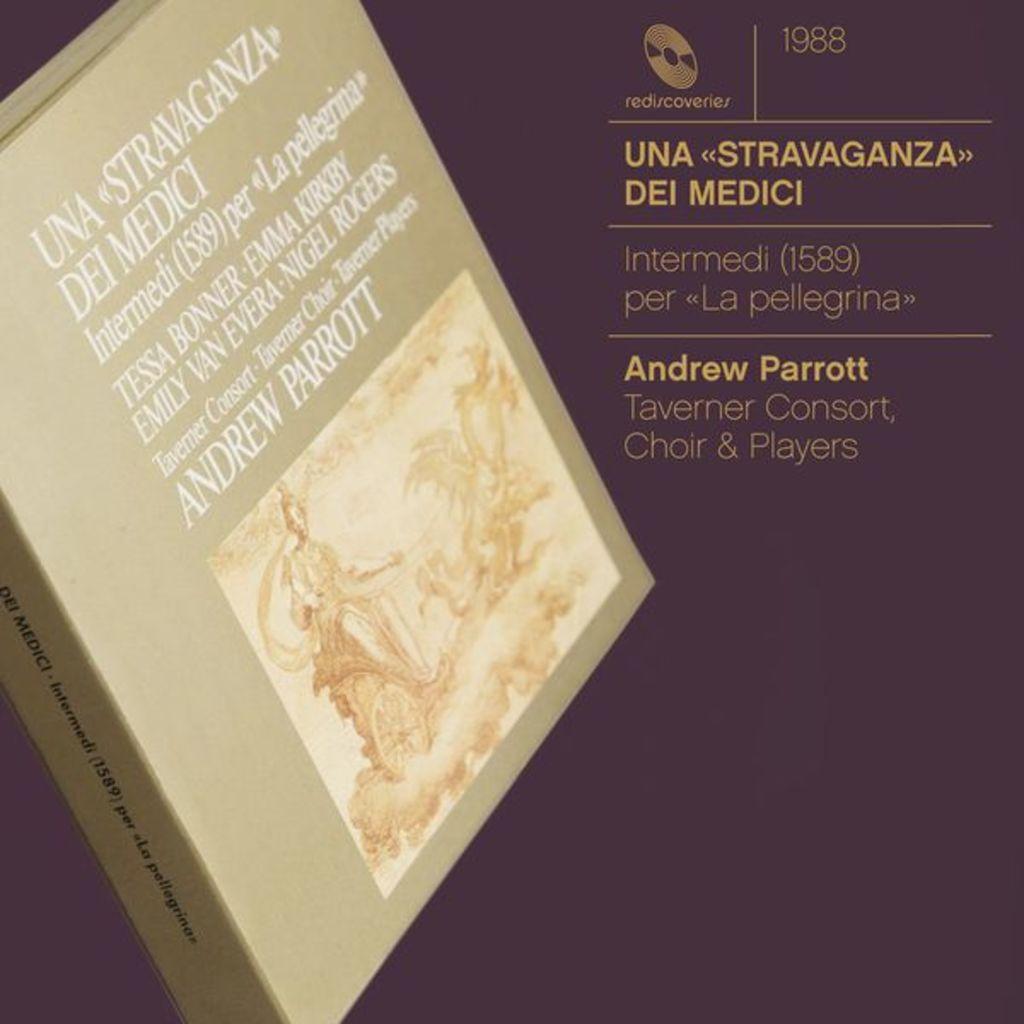What year is this album from?
Offer a terse response. 1988. 